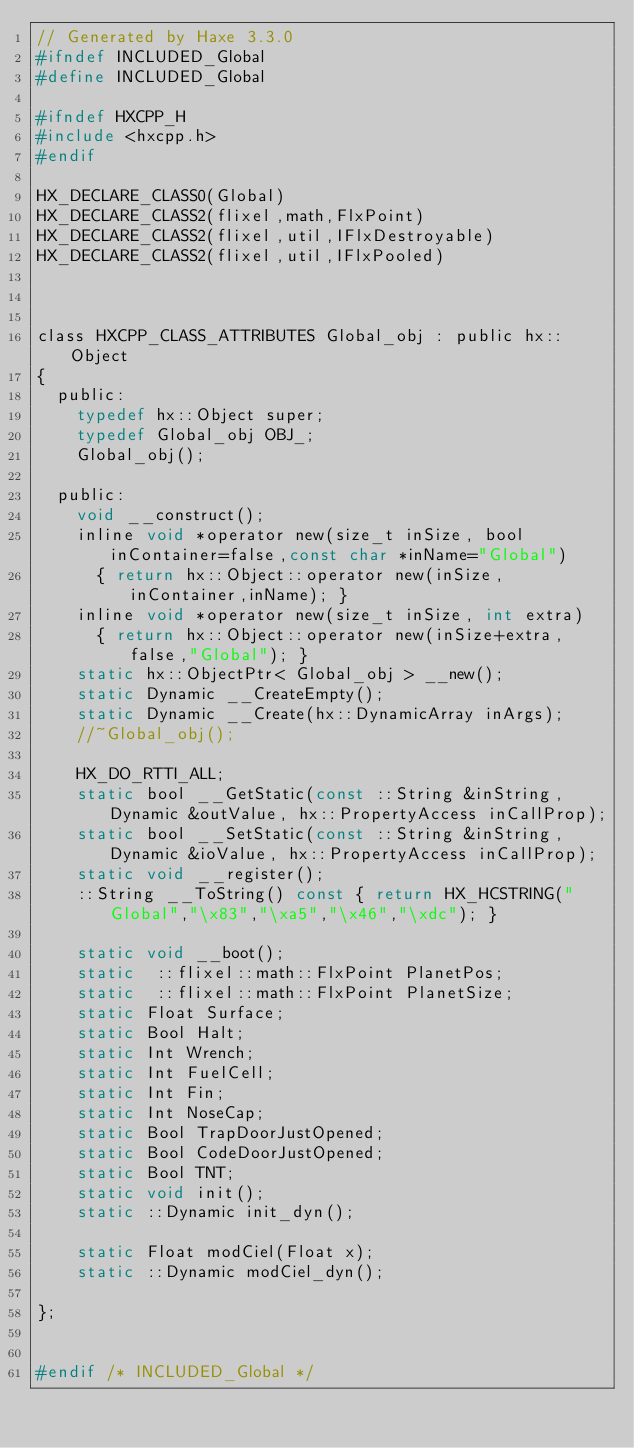Convert code to text. <code><loc_0><loc_0><loc_500><loc_500><_C_>// Generated by Haxe 3.3.0
#ifndef INCLUDED_Global
#define INCLUDED_Global

#ifndef HXCPP_H
#include <hxcpp.h>
#endif

HX_DECLARE_CLASS0(Global)
HX_DECLARE_CLASS2(flixel,math,FlxPoint)
HX_DECLARE_CLASS2(flixel,util,IFlxDestroyable)
HX_DECLARE_CLASS2(flixel,util,IFlxPooled)



class HXCPP_CLASS_ATTRIBUTES Global_obj : public hx::Object
{
	public:
		typedef hx::Object super;
		typedef Global_obj OBJ_;
		Global_obj();

	public:
		void __construct();
		inline void *operator new(size_t inSize, bool inContainer=false,const char *inName="Global")
			{ return hx::Object::operator new(inSize,inContainer,inName); }
		inline void *operator new(size_t inSize, int extra)
			{ return hx::Object::operator new(inSize+extra,false,"Global"); }
		static hx::ObjectPtr< Global_obj > __new();
		static Dynamic __CreateEmpty();
		static Dynamic __Create(hx::DynamicArray inArgs);
		//~Global_obj();

		HX_DO_RTTI_ALL;
		static bool __GetStatic(const ::String &inString, Dynamic &outValue, hx::PropertyAccess inCallProp);
		static bool __SetStatic(const ::String &inString, Dynamic &ioValue, hx::PropertyAccess inCallProp);
		static void __register();
		::String __ToString() const { return HX_HCSTRING("Global","\x83","\xa5","\x46","\xdc"); }

		static void __boot();
		static  ::flixel::math::FlxPoint PlanetPos;
		static  ::flixel::math::FlxPoint PlanetSize;
		static Float Surface;
		static Bool Halt;
		static Int Wrench;
		static Int FuelCell;
		static Int Fin;
		static Int NoseCap;
		static Bool TrapDoorJustOpened;
		static Bool CodeDoorJustOpened;
		static Bool TNT;
		static void init();
		static ::Dynamic init_dyn();

		static Float modCiel(Float x);
		static ::Dynamic modCiel_dyn();

};


#endif /* INCLUDED_Global */ 
</code> 